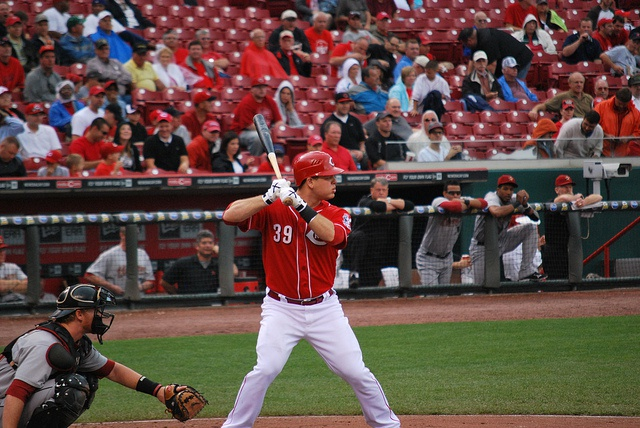Describe the objects in this image and their specific colors. I can see people in maroon, black, gray, and brown tones, people in maroon, lavender, and darkgray tones, people in maroon, black, gray, and darkgray tones, people in maroon, black, brown, and gray tones, and people in maroon, gray, and black tones in this image. 